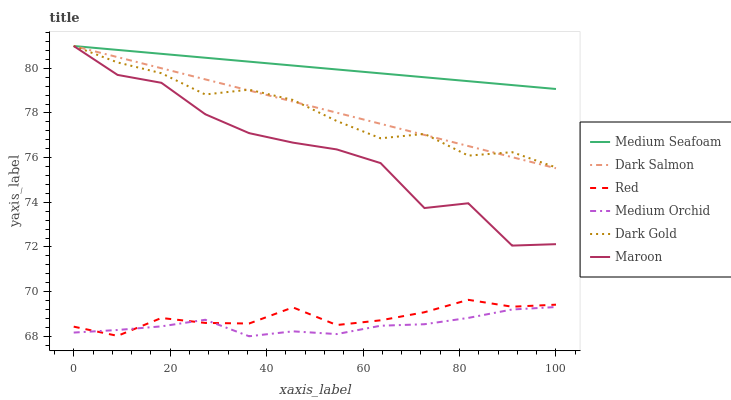Does Medium Orchid have the minimum area under the curve?
Answer yes or no. Yes. Does Medium Seafoam have the maximum area under the curve?
Answer yes or no. Yes. Does Dark Salmon have the minimum area under the curve?
Answer yes or no. No. Does Dark Salmon have the maximum area under the curve?
Answer yes or no. No. Is Dark Salmon the smoothest?
Answer yes or no. Yes. Is Maroon the roughest?
Answer yes or no. Yes. Is Medium Orchid the smoothest?
Answer yes or no. No. Is Medium Orchid the roughest?
Answer yes or no. No. Does Medium Orchid have the lowest value?
Answer yes or no. Yes. Does Dark Salmon have the lowest value?
Answer yes or no. No. Does Medium Seafoam have the highest value?
Answer yes or no. Yes. Does Medium Orchid have the highest value?
Answer yes or no. No. Is Red less than Dark Gold?
Answer yes or no. Yes. Is Maroon greater than Medium Orchid?
Answer yes or no. Yes. Does Dark Salmon intersect Maroon?
Answer yes or no. Yes. Is Dark Salmon less than Maroon?
Answer yes or no. No. Is Dark Salmon greater than Maroon?
Answer yes or no. No. Does Red intersect Dark Gold?
Answer yes or no. No. 